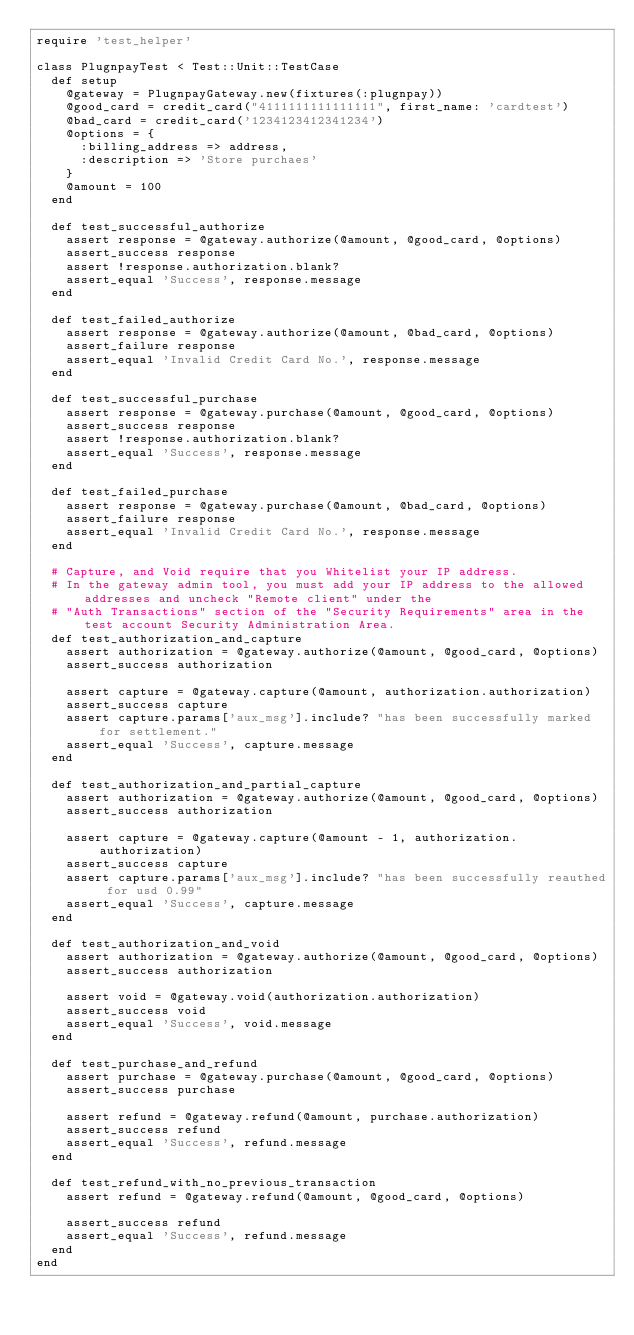<code> <loc_0><loc_0><loc_500><loc_500><_Ruby_>require 'test_helper'

class PlugnpayTest < Test::Unit::TestCase
  def setup
    @gateway = PlugnpayGateway.new(fixtures(:plugnpay))
    @good_card = credit_card("4111111111111111", first_name: 'cardtest')
    @bad_card = credit_card('1234123412341234')
    @options = {
      :billing_address => address,
      :description => 'Store purchaes'
    }
    @amount = 100
  end

  def test_successful_authorize
    assert response = @gateway.authorize(@amount, @good_card, @options)
    assert_success response
    assert !response.authorization.blank?
    assert_equal 'Success', response.message
  end

  def test_failed_authorize
    assert response = @gateway.authorize(@amount, @bad_card, @options)
    assert_failure response
    assert_equal 'Invalid Credit Card No.', response.message
  end

  def test_successful_purchase
    assert response = @gateway.purchase(@amount, @good_card, @options)
    assert_success response
    assert !response.authorization.blank?
    assert_equal 'Success', response.message
  end

  def test_failed_purchase
    assert response = @gateway.purchase(@amount, @bad_card, @options)
    assert_failure response
    assert_equal 'Invalid Credit Card No.', response.message
  end

  # Capture, and Void require that you Whitelist your IP address.
  # In the gateway admin tool, you must add your IP address to the allowed addresses and uncheck "Remote client" under the
  # "Auth Transactions" section of the "Security Requirements" area in the test account Security Administration Area.
  def test_authorization_and_capture
    assert authorization = @gateway.authorize(@amount, @good_card, @options)
    assert_success authorization

    assert capture = @gateway.capture(@amount, authorization.authorization)
    assert_success capture
    assert capture.params['aux_msg'].include? "has been successfully marked for settlement."
    assert_equal 'Success', capture.message
  end

  def test_authorization_and_partial_capture
    assert authorization = @gateway.authorize(@amount, @good_card, @options)
    assert_success authorization

    assert capture = @gateway.capture(@amount - 1, authorization.authorization)
    assert_success capture
    assert capture.params['aux_msg'].include? "has been successfully reauthed for usd 0.99"
    assert_equal 'Success', capture.message
  end

  def test_authorization_and_void
    assert authorization = @gateway.authorize(@amount, @good_card, @options)
    assert_success authorization

    assert void = @gateway.void(authorization.authorization)
    assert_success void
    assert_equal 'Success', void.message
  end

  def test_purchase_and_refund
    assert purchase = @gateway.purchase(@amount, @good_card, @options)
    assert_success purchase

    assert refund = @gateway.refund(@amount, purchase.authorization)
    assert_success refund
    assert_equal 'Success', refund.message
  end

  def test_refund_with_no_previous_transaction
    assert refund = @gateway.refund(@amount, @good_card, @options)

    assert_success refund
    assert_equal 'Success', refund.message
  end
end
</code> 